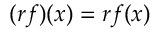Convert formula to latex. <formula><loc_0><loc_0><loc_500><loc_500>( r f ) ( x ) = r f ( x )</formula> 